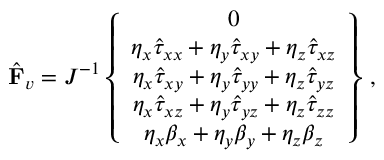Convert formula to latex. <formula><loc_0><loc_0><loc_500><loc_500>\hat { F } _ { v } = J ^ { - 1 } \left \{ \begin{array} { c } { 0 } \\ { \eta _ { x } \hat { \tau } _ { x x } + \eta _ { y } \hat { \tau } _ { x y } + \eta _ { z } \hat { \tau } _ { x z } } \\ { \eta _ { x } \hat { \tau } _ { x y } + \eta _ { y } \hat { \tau } _ { y y } + \eta _ { z } \hat { \tau } _ { y z } } \\ { \eta _ { x } \hat { \tau } _ { x z } + \eta _ { y } \hat { \tau } _ { y z } + \eta _ { z } \hat { \tau } _ { z z } } \\ { \eta _ { x } { \beta } _ { x } + \eta _ { y } { \beta } _ { y } + \eta _ { z } { \beta } _ { z } } \end{array} \right \} \, ,</formula> 